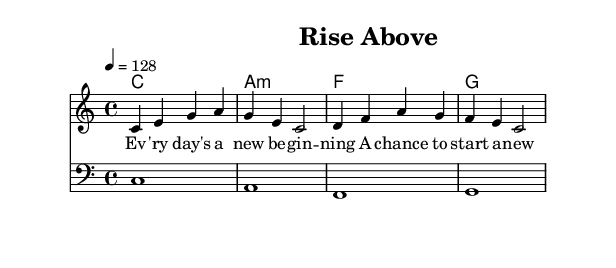What is the key signature of this music? The key signature indicated is C major, which is noted at the beginning of the score and signifies there are no sharps or flats.
Answer: C major What is the time signature of this piece? The time signature is shown as 4/4 at the beginning, indicating that there are four beats per measure and the quarter note gets the beat.
Answer: 4/4 What is the tempo marking for this composition? The tempo marking provided is 4 = 128, meaning the piece should be played at a speed of 128 beats per minute.
Answer: 128 How many measures does the melody contain? Counting the visible measures in the melody section of the score, there are four measures in total.
Answer: 4 Identify the first lyric of the song. The score starts with the lyric "Ev" which is part of the phrase "Ev'ry day's a new beginning" in the verse section.
Answer: Ev'ry What is the chord progression used throughout the piece? Analyzing the chord mode, the progression utilized in this piece is C major, A minor, F major, and G major in sequence.
Answer: C, A minor, F, G What is the clef used for the bassline? The bassline is marked with a bass clef, which indicates the pitch range for the lower notes played.
Answer: Bass clef 